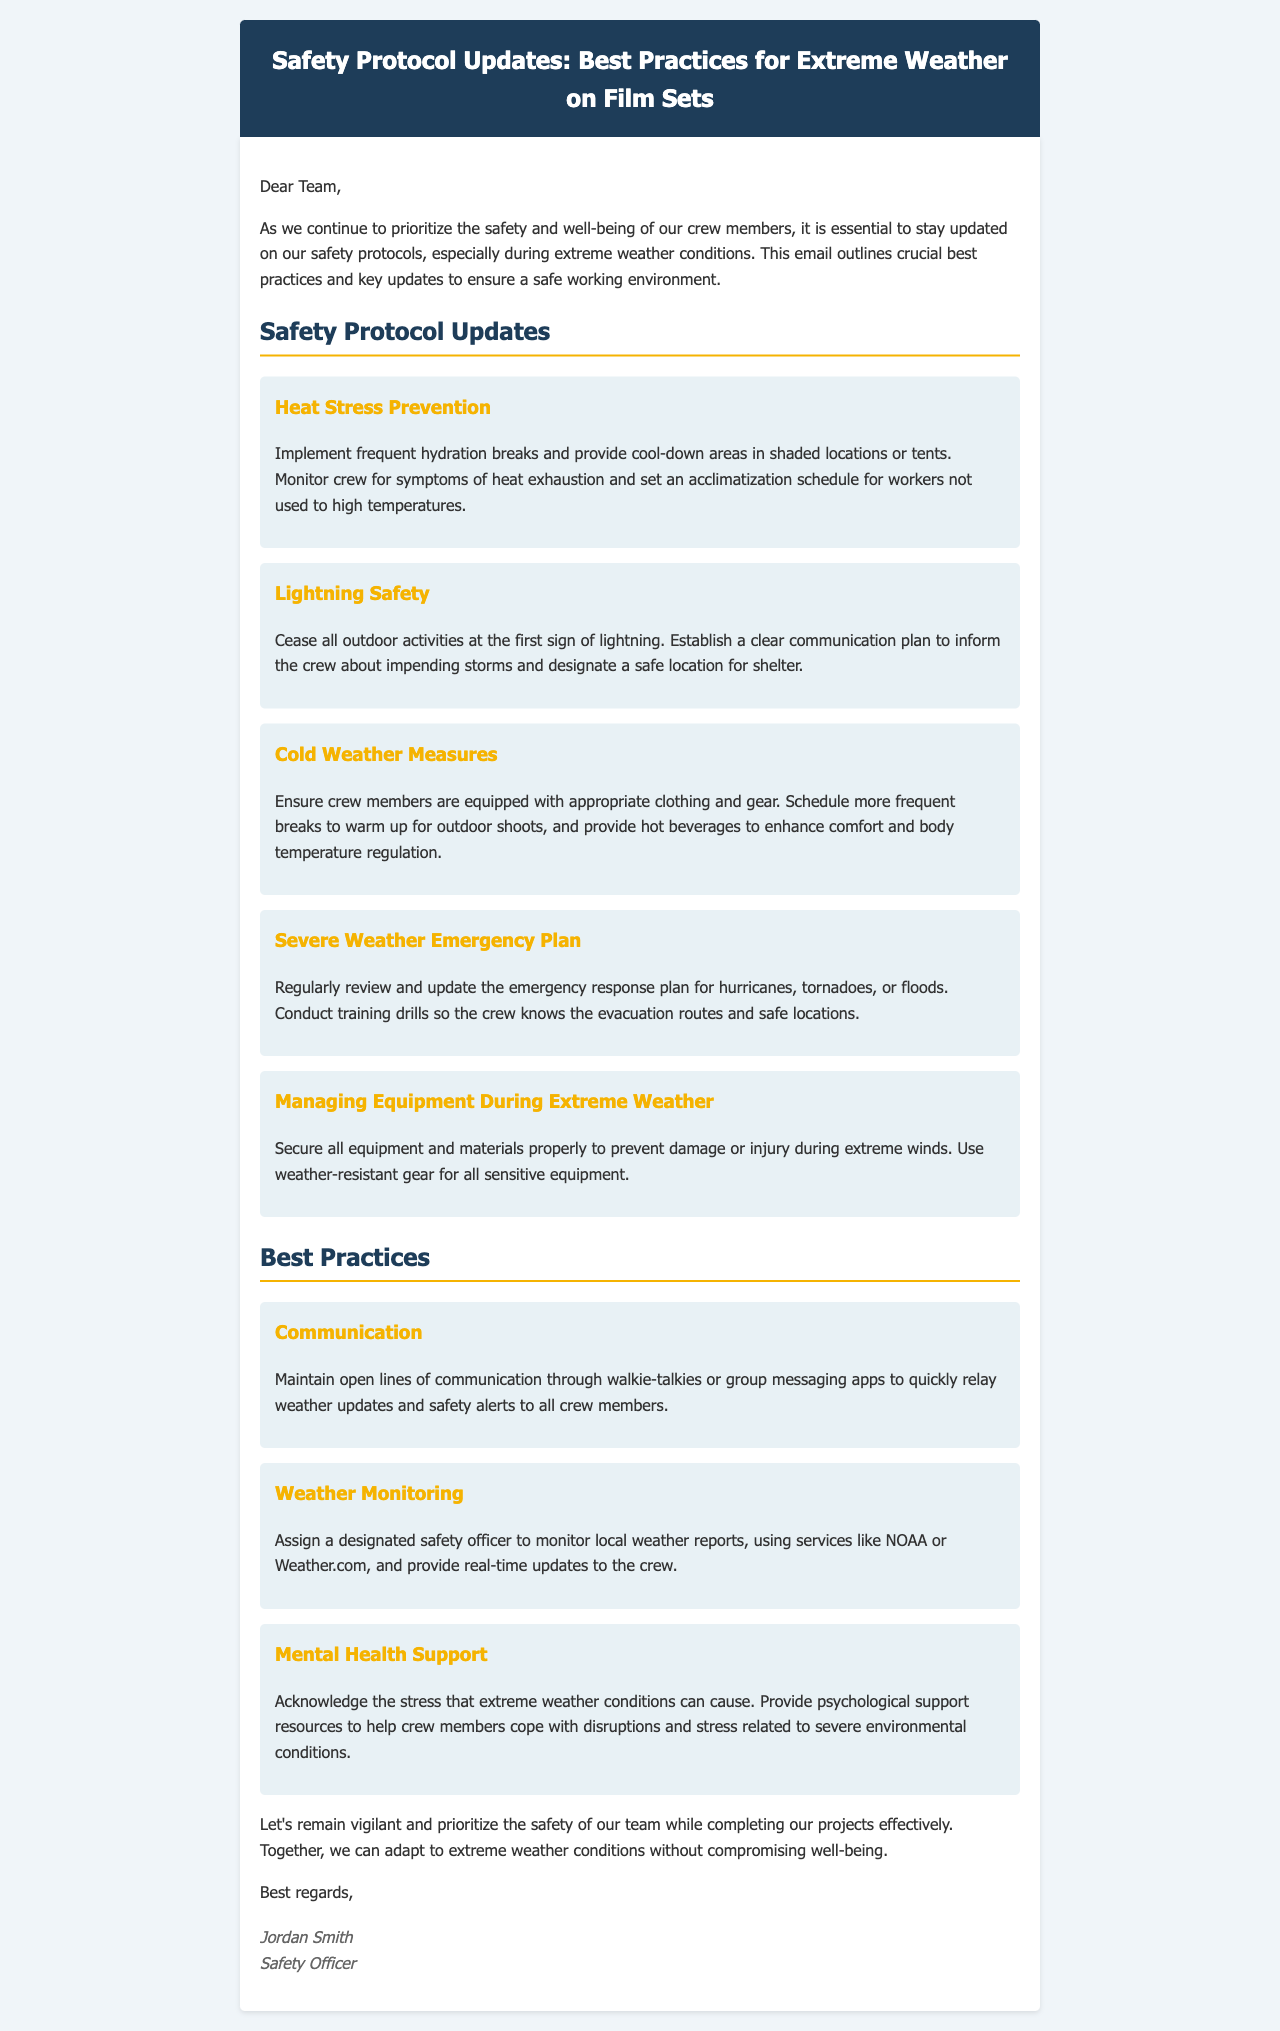What are the key updates in safety protocols? The key updates in safety protocols include heat stress prevention, lightning safety, cold weather measures, severe weather emergency plan, and managing equipment during extreme weather.
Answer: Safety Protocol Updates What is the first safety protocol mentioned for extreme weather? The first safety protocol mentioned is for heat stress prevention, which focuses on hydration and monitoring crew symptoms.
Answer: Heat Stress Prevention Who is assigned to monitor local weather reports? A designated safety officer is responsible for monitoring local weather reports and providing updates to the crew.
Answer: Designated safety officer What should be done at the first sign of lightning? All outdoor activities should cease at the first sign of lightning according to the safety protocols.
Answer: Cease all outdoor activities What is a suggested practice for mental health support? Providing psychological support resources to help crew members cope with stress related to severe weather is suggested.
Answer: Psychological support resources How often should breaks be scheduled during cold weather? More frequent breaks should be scheduled to warm up during outdoor shoots in cold weather conditions.
Answer: More frequent breaks What is essential to ensure during heat stress prevention? Implementing frequent hydration breaks is essential to prevent heat stress among crew members.
Answer: Frequent hydration breaks What should be secured properly during extreme winds? All equipment and materials should be secured properly to prevent damage or injury during extreme winds.
Answer: All equipment and materials 